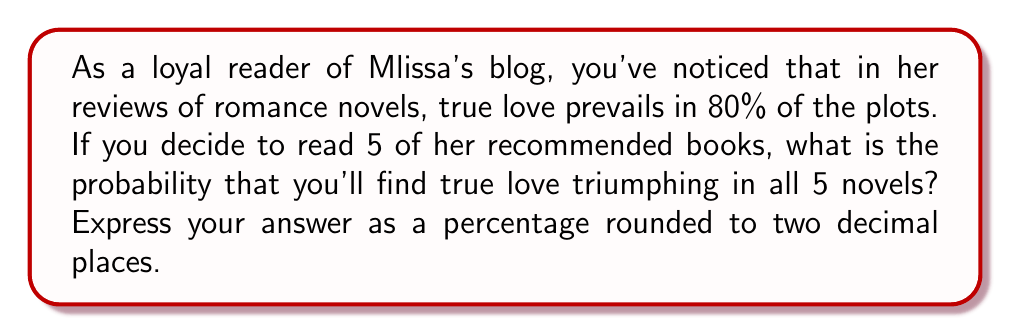Provide a solution to this math problem. Let's approach this step-by-step:

1) The probability of true love prevailing in a single novel is 80% or 0.8.

2) We want to find the probability of this happening in all 5 novels. This is an example of independent events, where the outcome of one doesn't affect the others.

3) For independent events, we multiply the individual probabilities:

   $P(\text{all 5 novels have true love}) = 0.8 \times 0.8 \times 0.8 \times 0.8 \times 0.8$

4) This is equivalent to:

   $P(\text{all 5 novels have true love}) = 0.8^5$

5) Let's calculate this:

   $0.8^5 = 0.32768$

6) To convert to a percentage, we multiply by 100:

   $0.32768 \times 100 = 32.768\%$

7) Rounding to two decimal places:

   $32.768\% \approx 32.77\%$
Answer: $32.77\%$ 